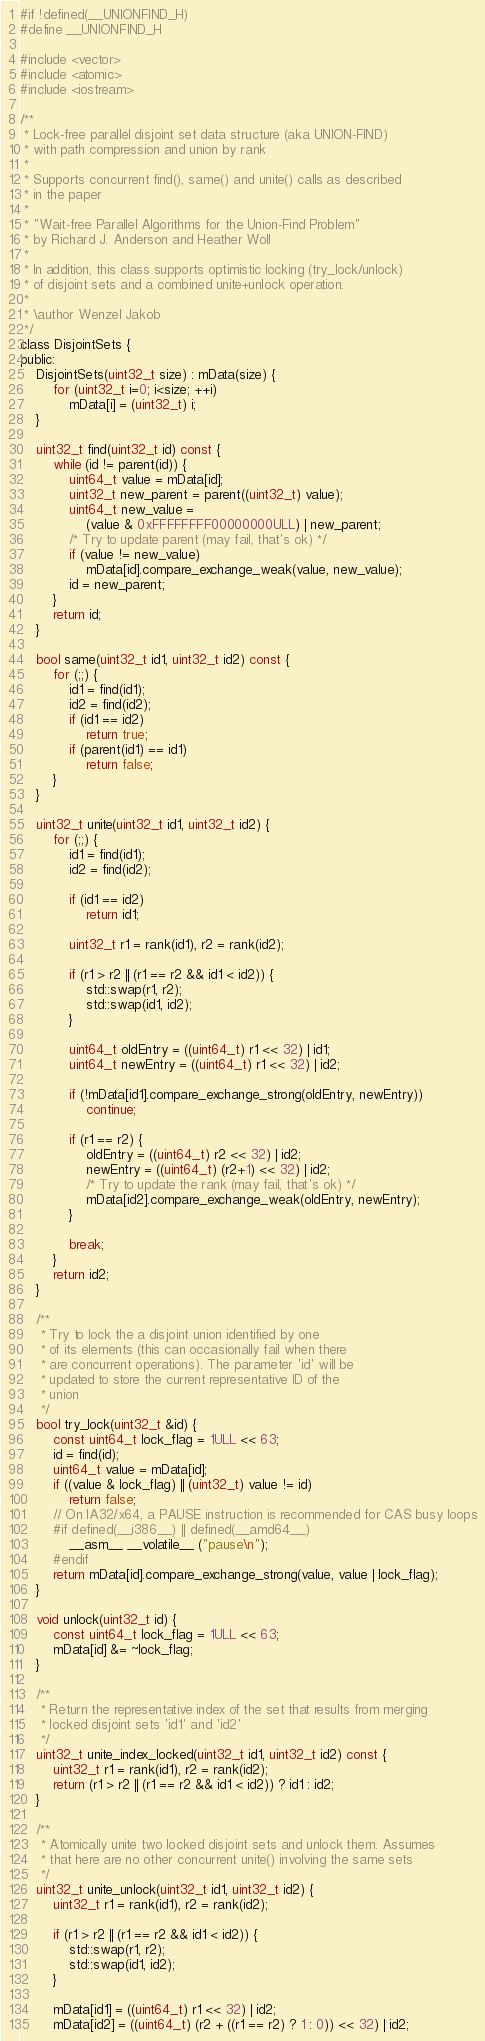<code> <loc_0><loc_0><loc_500><loc_500><_C_>#if !defined(__UNIONFIND_H)
#define __UNIONFIND_H

#include <vector>
#include <atomic>
#include <iostream>

/**
 * Lock-free parallel disjoint set data structure (aka UNION-FIND)
 * with path compression and union by rank
 *
 * Supports concurrent find(), same() and unite() calls as described
 * in the paper
 *
 * "Wait-free Parallel Algorithms for the Union-Find Problem"
 * by Richard J. Anderson and Heather Woll
 *
 * In addition, this class supports optimistic locking (try_lock/unlock)
 * of disjoint sets and a combined unite+unlock operation.
 *
 * \author Wenzel Jakob
 */
class DisjointSets {
public:
    DisjointSets(uint32_t size) : mData(size) {
        for (uint32_t i=0; i<size; ++i)
            mData[i] = (uint32_t) i;
    }

    uint32_t find(uint32_t id) const {
        while (id != parent(id)) {
            uint64_t value = mData[id];
            uint32_t new_parent = parent((uint32_t) value);
            uint64_t new_value =
                (value & 0xFFFFFFFF00000000ULL) | new_parent;
            /* Try to update parent (may fail, that's ok) */
            if (value != new_value)
                mData[id].compare_exchange_weak(value, new_value);
            id = new_parent;
        }
        return id;
    }

    bool same(uint32_t id1, uint32_t id2) const {
        for (;;) {
            id1 = find(id1);
            id2 = find(id2);
            if (id1 == id2)
                return true;
            if (parent(id1) == id1)
                return false;
        }
    }

    uint32_t unite(uint32_t id1, uint32_t id2) {
        for (;;) {
            id1 = find(id1);
            id2 = find(id2);

            if (id1 == id2)
                return id1;

            uint32_t r1 = rank(id1), r2 = rank(id2);

            if (r1 > r2 || (r1 == r2 && id1 < id2)) {
                std::swap(r1, r2);
                std::swap(id1, id2);
            }

            uint64_t oldEntry = ((uint64_t) r1 << 32) | id1;
            uint64_t newEntry = ((uint64_t) r1 << 32) | id2;

            if (!mData[id1].compare_exchange_strong(oldEntry, newEntry))
                continue;

            if (r1 == r2) {
                oldEntry = ((uint64_t) r2 << 32) | id2;
                newEntry = ((uint64_t) (r2+1) << 32) | id2;
                /* Try to update the rank (may fail, that's ok) */
                mData[id2].compare_exchange_weak(oldEntry, newEntry);
            }

            break;
        }
        return id2;
    }

    /**
     * Try to lock the a disjoint union identified by one
     * of its elements (this can occasionally fail when there
     * are concurrent operations). The parameter 'id' will be
     * updated to store the current representative ID of the
     * union
     */
    bool try_lock(uint32_t &id) {
        const uint64_t lock_flag = 1ULL << 63;
        id = find(id);
        uint64_t value = mData[id];
        if ((value & lock_flag) || (uint32_t) value != id)
            return false;
        // On IA32/x64, a PAUSE instruction is recommended for CAS busy loops
        #if defined(__i386__) || defined(__amd64__)
            __asm__ __volatile__ ("pause\n");
        #endif
        return mData[id].compare_exchange_strong(value, value | lock_flag);
    }

    void unlock(uint32_t id) {
        const uint64_t lock_flag = 1ULL << 63;
        mData[id] &= ~lock_flag;
    }

    /**
     * Return the representative index of the set that results from merging
     * locked disjoint sets 'id1' and 'id2'
     */
    uint32_t unite_index_locked(uint32_t id1, uint32_t id2) const {
        uint32_t r1 = rank(id1), r2 = rank(id2);
        return (r1 > r2 || (r1 == r2 && id1 < id2)) ? id1 : id2;
    }

    /**
     * Atomically unite two locked disjoint sets and unlock them. Assumes
     * that here are no other concurrent unite() involving the same sets
     */
    uint32_t unite_unlock(uint32_t id1, uint32_t id2) {
        uint32_t r1 = rank(id1), r2 = rank(id2);

        if (r1 > r2 || (r1 == r2 && id1 < id2)) {
            std::swap(r1, r2);
            std::swap(id1, id2);
        }

        mData[id1] = ((uint64_t) r1 << 32) | id2;
        mData[id2] = ((uint64_t) (r2 + ((r1 == r2) ? 1 : 0)) << 32) | id2;
</code> 